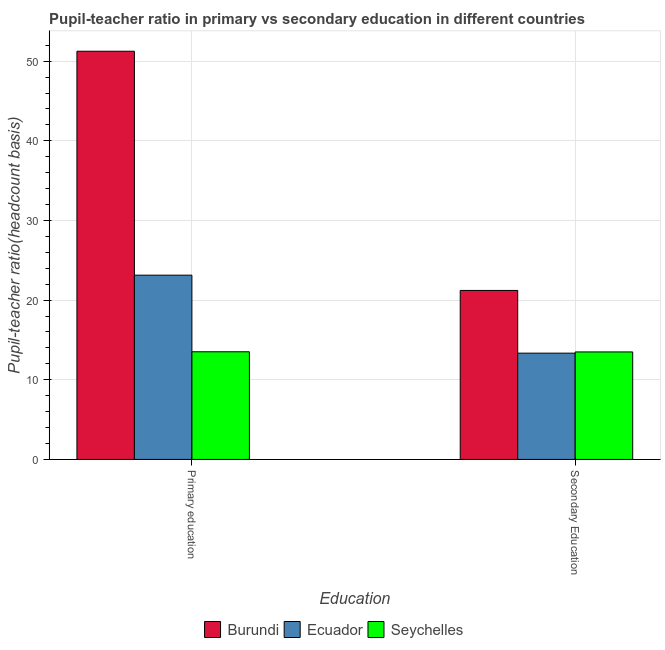How many groups of bars are there?
Make the answer very short. 2. How many bars are there on the 1st tick from the left?
Ensure brevity in your answer.  3. What is the label of the 2nd group of bars from the left?
Provide a short and direct response. Secondary Education. What is the pupil teacher ratio on secondary education in Seychelles?
Give a very brief answer. 13.49. Across all countries, what is the maximum pupil-teacher ratio in primary education?
Provide a succinct answer. 51.25. Across all countries, what is the minimum pupil teacher ratio on secondary education?
Keep it short and to the point. 13.34. In which country was the pupil teacher ratio on secondary education maximum?
Give a very brief answer. Burundi. In which country was the pupil-teacher ratio in primary education minimum?
Offer a very short reply. Seychelles. What is the total pupil-teacher ratio in primary education in the graph?
Your answer should be compact. 87.89. What is the difference between the pupil teacher ratio on secondary education in Burundi and that in Ecuador?
Your answer should be compact. 7.87. What is the difference between the pupil-teacher ratio in primary education in Burundi and the pupil teacher ratio on secondary education in Seychelles?
Provide a short and direct response. 37.75. What is the average pupil-teacher ratio in primary education per country?
Your response must be concise. 29.3. What is the difference between the pupil-teacher ratio in primary education and pupil teacher ratio on secondary education in Burundi?
Provide a succinct answer. 30.03. In how many countries, is the pupil-teacher ratio in primary education greater than 46 ?
Keep it short and to the point. 1. What is the ratio of the pupil teacher ratio on secondary education in Burundi to that in Ecuador?
Your response must be concise. 1.59. In how many countries, is the pupil-teacher ratio in primary education greater than the average pupil-teacher ratio in primary education taken over all countries?
Your response must be concise. 1. What does the 2nd bar from the left in Secondary Education represents?
Give a very brief answer. Ecuador. What does the 3rd bar from the right in Secondary Education represents?
Your answer should be compact. Burundi. How many bars are there?
Offer a terse response. 6. Are all the bars in the graph horizontal?
Give a very brief answer. No. What is the difference between two consecutive major ticks on the Y-axis?
Your answer should be very brief. 10. Does the graph contain any zero values?
Your response must be concise. No. Does the graph contain grids?
Ensure brevity in your answer.  Yes. How are the legend labels stacked?
Ensure brevity in your answer.  Horizontal. What is the title of the graph?
Your answer should be compact. Pupil-teacher ratio in primary vs secondary education in different countries. What is the label or title of the X-axis?
Offer a very short reply. Education. What is the label or title of the Y-axis?
Ensure brevity in your answer.  Pupil-teacher ratio(headcount basis). What is the Pupil-teacher ratio(headcount basis) of Burundi in Primary education?
Ensure brevity in your answer.  51.25. What is the Pupil-teacher ratio(headcount basis) in Ecuador in Primary education?
Provide a short and direct response. 23.13. What is the Pupil-teacher ratio(headcount basis) of Seychelles in Primary education?
Provide a short and direct response. 13.51. What is the Pupil-teacher ratio(headcount basis) in Burundi in Secondary Education?
Your response must be concise. 21.22. What is the Pupil-teacher ratio(headcount basis) of Ecuador in Secondary Education?
Give a very brief answer. 13.34. What is the Pupil-teacher ratio(headcount basis) in Seychelles in Secondary Education?
Offer a terse response. 13.49. Across all Education, what is the maximum Pupil-teacher ratio(headcount basis) in Burundi?
Give a very brief answer. 51.25. Across all Education, what is the maximum Pupil-teacher ratio(headcount basis) in Ecuador?
Your response must be concise. 23.13. Across all Education, what is the maximum Pupil-teacher ratio(headcount basis) of Seychelles?
Offer a terse response. 13.51. Across all Education, what is the minimum Pupil-teacher ratio(headcount basis) in Burundi?
Offer a very short reply. 21.22. Across all Education, what is the minimum Pupil-teacher ratio(headcount basis) of Ecuador?
Offer a terse response. 13.34. Across all Education, what is the minimum Pupil-teacher ratio(headcount basis) in Seychelles?
Your response must be concise. 13.49. What is the total Pupil-teacher ratio(headcount basis) of Burundi in the graph?
Offer a terse response. 72.46. What is the total Pupil-teacher ratio(headcount basis) of Ecuador in the graph?
Your answer should be compact. 36.48. What is the total Pupil-teacher ratio(headcount basis) of Seychelles in the graph?
Provide a succinct answer. 27.01. What is the difference between the Pupil-teacher ratio(headcount basis) of Burundi in Primary education and that in Secondary Education?
Provide a short and direct response. 30.03. What is the difference between the Pupil-teacher ratio(headcount basis) of Ecuador in Primary education and that in Secondary Education?
Your response must be concise. 9.79. What is the difference between the Pupil-teacher ratio(headcount basis) of Seychelles in Primary education and that in Secondary Education?
Offer a very short reply. 0.02. What is the difference between the Pupil-teacher ratio(headcount basis) in Burundi in Primary education and the Pupil-teacher ratio(headcount basis) in Ecuador in Secondary Education?
Provide a short and direct response. 37.9. What is the difference between the Pupil-teacher ratio(headcount basis) of Burundi in Primary education and the Pupil-teacher ratio(headcount basis) of Seychelles in Secondary Education?
Your answer should be compact. 37.75. What is the difference between the Pupil-teacher ratio(headcount basis) in Ecuador in Primary education and the Pupil-teacher ratio(headcount basis) in Seychelles in Secondary Education?
Your answer should be very brief. 9.64. What is the average Pupil-teacher ratio(headcount basis) of Burundi per Education?
Your response must be concise. 36.23. What is the average Pupil-teacher ratio(headcount basis) of Ecuador per Education?
Make the answer very short. 18.24. What is the average Pupil-teacher ratio(headcount basis) in Seychelles per Education?
Keep it short and to the point. 13.5. What is the difference between the Pupil-teacher ratio(headcount basis) in Burundi and Pupil-teacher ratio(headcount basis) in Ecuador in Primary education?
Provide a succinct answer. 28.11. What is the difference between the Pupil-teacher ratio(headcount basis) of Burundi and Pupil-teacher ratio(headcount basis) of Seychelles in Primary education?
Offer a very short reply. 37.73. What is the difference between the Pupil-teacher ratio(headcount basis) of Ecuador and Pupil-teacher ratio(headcount basis) of Seychelles in Primary education?
Keep it short and to the point. 9.62. What is the difference between the Pupil-teacher ratio(headcount basis) in Burundi and Pupil-teacher ratio(headcount basis) in Ecuador in Secondary Education?
Your answer should be compact. 7.87. What is the difference between the Pupil-teacher ratio(headcount basis) in Burundi and Pupil-teacher ratio(headcount basis) in Seychelles in Secondary Education?
Make the answer very short. 7.72. What is the difference between the Pupil-teacher ratio(headcount basis) of Ecuador and Pupil-teacher ratio(headcount basis) of Seychelles in Secondary Education?
Provide a short and direct response. -0.15. What is the ratio of the Pupil-teacher ratio(headcount basis) in Burundi in Primary education to that in Secondary Education?
Your answer should be very brief. 2.42. What is the ratio of the Pupil-teacher ratio(headcount basis) of Ecuador in Primary education to that in Secondary Education?
Make the answer very short. 1.73. What is the ratio of the Pupil-teacher ratio(headcount basis) of Seychelles in Primary education to that in Secondary Education?
Your response must be concise. 1. What is the difference between the highest and the second highest Pupil-teacher ratio(headcount basis) of Burundi?
Provide a succinct answer. 30.03. What is the difference between the highest and the second highest Pupil-teacher ratio(headcount basis) of Ecuador?
Your response must be concise. 9.79. What is the difference between the highest and the second highest Pupil-teacher ratio(headcount basis) of Seychelles?
Your response must be concise. 0.02. What is the difference between the highest and the lowest Pupil-teacher ratio(headcount basis) of Burundi?
Provide a short and direct response. 30.03. What is the difference between the highest and the lowest Pupil-teacher ratio(headcount basis) in Ecuador?
Your response must be concise. 9.79. What is the difference between the highest and the lowest Pupil-teacher ratio(headcount basis) in Seychelles?
Your answer should be compact. 0.02. 